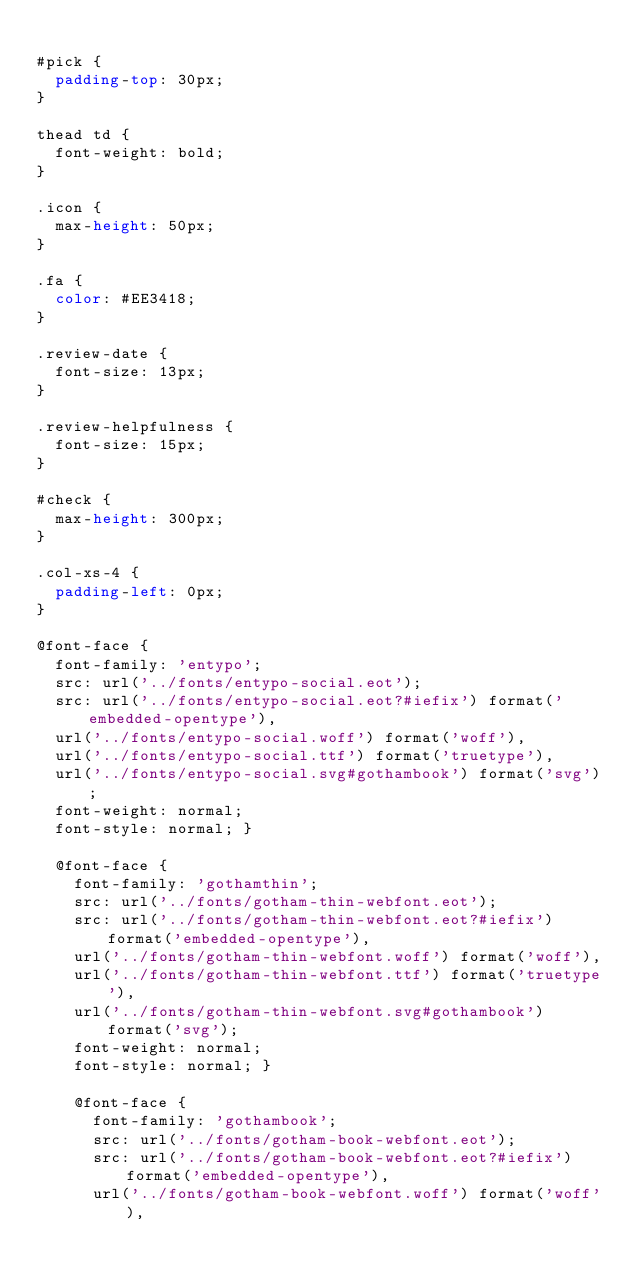Convert code to text. <code><loc_0><loc_0><loc_500><loc_500><_CSS_>
#pick {
  padding-top: 30px;
}

thead td {
  font-weight: bold;
}

.icon {
  max-height: 50px;
}

.fa {
  color: #EE3418;
}

.review-date {
  font-size: 13px;
}

.review-helpfulness {
  font-size: 15px;
}

#check {
  max-height: 300px;
}

.col-xs-4 {
  padding-left: 0px;
}

@font-face {
  font-family: 'entypo';
  src: url('../fonts/entypo-social.eot');
  src: url('../fonts/entypo-social.eot?#iefix') format('embedded-opentype'),
  url('../fonts/entypo-social.woff') format('woff'),
  url('../fonts/entypo-social.ttf') format('truetype'),
  url('../fonts/entypo-social.svg#gothambook') format('svg');
  font-weight: normal;
  font-style: normal; }

  @font-face {
    font-family: 'gothamthin';
    src: url('../fonts/gotham-thin-webfont.eot');
    src: url('../fonts/gotham-thin-webfont.eot?#iefix') format('embedded-opentype'),
    url('../fonts/gotham-thin-webfont.woff') format('woff'),
    url('../fonts/gotham-thin-webfont.ttf') format('truetype'),
    url('../fonts/gotham-thin-webfont.svg#gothambook') format('svg');
    font-weight: normal;
    font-style: normal; }

    @font-face {
      font-family: 'gothambook';
      src: url('../fonts/gotham-book-webfont.eot');
      src: url('../fonts/gotham-book-webfont.eot?#iefix') format('embedded-opentype'),
      url('../fonts/gotham-book-webfont.woff') format('woff'),</code> 